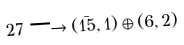Convert formula to latex. <formula><loc_0><loc_0><loc_500><loc_500>2 7 \longrightarrow ( { \bar { 1 5 } } , 1 ) \oplus ( 6 , 2 ) \,</formula> 